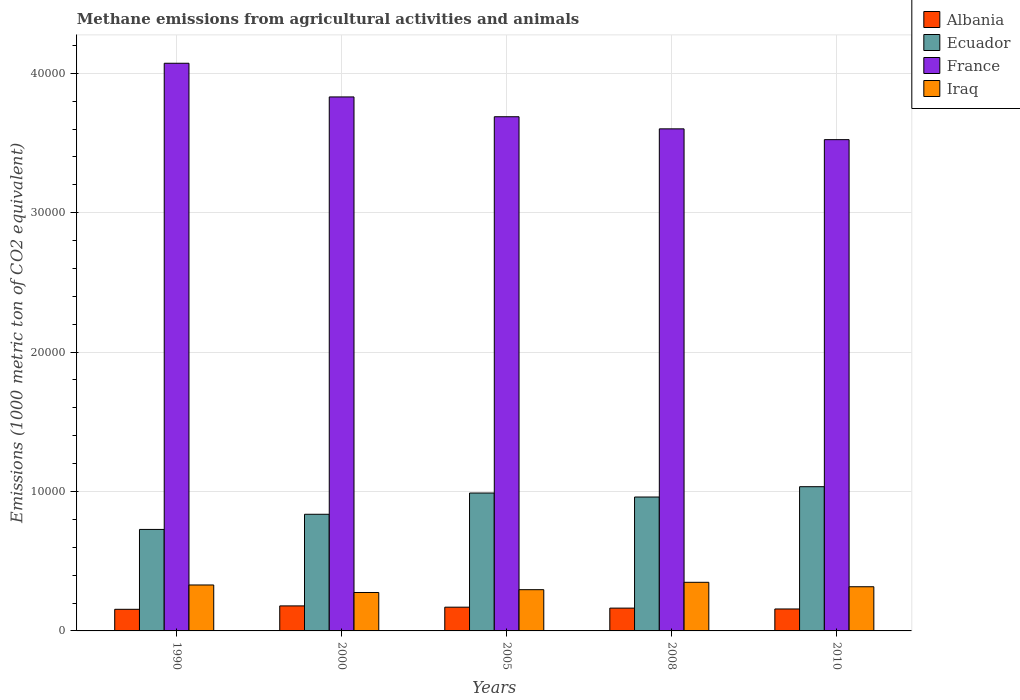How many bars are there on the 3rd tick from the right?
Provide a succinct answer. 4. What is the label of the 5th group of bars from the left?
Your answer should be compact. 2010. In how many cases, is the number of bars for a given year not equal to the number of legend labels?
Offer a terse response. 0. What is the amount of methane emitted in Albania in 2000?
Provide a succinct answer. 1794.6. Across all years, what is the maximum amount of methane emitted in Albania?
Offer a very short reply. 1794.6. Across all years, what is the minimum amount of methane emitted in Iraq?
Make the answer very short. 2756.2. In which year was the amount of methane emitted in Albania maximum?
Provide a short and direct response. 2000. What is the total amount of methane emitted in Iraq in the graph?
Give a very brief answer. 1.57e+04. What is the difference between the amount of methane emitted in Ecuador in 1990 and that in 2010?
Offer a very short reply. -3065.8. What is the difference between the amount of methane emitted in Iraq in 2000 and the amount of methane emitted in Ecuador in 2010?
Provide a short and direct response. -7589.6. What is the average amount of methane emitted in Albania per year?
Ensure brevity in your answer.  1651.66. In the year 2010, what is the difference between the amount of methane emitted in Ecuador and amount of methane emitted in France?
Give a very brief answer. -2.49e+04. In how many years, is the amount of methane emitted in Albania greater than 10000 1000 metric ton?
Ensure brevity in your answer.  0. What is the ratio of the amount of methane emitted in France in 2000 to that in 2010?
Provide a succinct answer. 1.09. Is the amount of methane emitted in Ecuador in 1990 less than that in 2008?
Make the answer very short. Yes. What is the difference between the highest and the second highest amount of methane emitted in Iraq?
Ensure brevity in your answer.  191.6. What is the difference between the highest and the lowest amount of methane emitted in France?
Offer a terse response. 5479. Is it the case that in every year, the sum of the amount of methane emitted in Ecuador and amount of methane emitted in Iraq is greater than the sum of amount of methane emitted in Albania and amount of methane emitted in France?
Your answer should be compact. No. What does the 1st bar from the left in 2010 represents?
Provide a short and direct response. Albania. How many bars are there?
Ensure brevity in your answer.  20. Are all the bars in the graph horizontal?
Your answer should be very brief. No. What is the difference between two consecutive major ticks on the Y-axis?
Provide a short and direct response. 10000. Are the values on the major ticks of Y-axis written in scientific E-notation?
Ensure brevity in your answer.  No. How are the legend labels stacked?
Give a very brief answer. Vertical. What is the title of the graph?
Ensure brevity in your answer.  Methane emissions from agricultural activities and animals. What is the label or title of the Y-axis?
Keep it short and to the point. Emissions (1000 metric ton of CO2 equivalent). What is the Emissions (1000 metric ton of CO2 equivalent) of Albania in 1990?
Offer a very short reply. 1550.9. What is the Emissions (1000 metric ton of CO2 equivalent) in Ecuador in 1990?
Keep it short and to the point. 7280. What is the Emissions (1000 metric ton of CO2 equivalent) of France in 1990?
Your answer should be compact. 4.07e+04. What is the Emissions (1000 metric ton of CO2 equivalent) of Iraq in 1990?
Your answer should be compact. 3295.9. What is the Emissions (1000 metric ton of CO2 equivalent) in Albania in 2000?
Keep it short and to the point. 1794.6. What is the Emissions (1000 metric ton of CO2 equivalent) in Ecuador in 2000?
Ensure brevity in your answer.  8366.7. What is the Emissions (1000 metric ton of CO2 equivalent) in France in 2000?
Your response must be concise. 3.83e+04. What is the Emissions (1000 metric ton of CO2 equivalent) of Iraq in 2000?
Offer a very short reply. 2756.2. What is the Emissions (1000 metric ton of CO2 equivalent) of Albania in 2005?
Your response must be concise. 1702.9. What is the Emissions (1000 metric ton of CO2 equivalent) of Ecuador in 2005?
Offer a very short reply. 9891. What is the Emissions (1000 metric ton of CO2 equivalent) of France in 2005?
Your response must be concise. 3.69e+04. What is the Emissions (1000 metric ton of CO2 equivalent) of Iraq in 2005?
Give a very brief answer. 2958.3. What is the Emissions (1000 metric ton of CO2 equivalent) in Albania in 2008?
Your response must be concise. 1635.8. What is the Emissions (1000 metric ton of CO2 equivalent) in Ecuador in 2008?
Make the answer very short. 9604.8. What is the Emissions (1000 metric ton of CO2 equivalent) of France in 2008?
Provide a succinct answer. 3.60e+04. What is the Emissions (1000 metric ton of CO2 equivalent) of Iraq in 2008?
Provide a succinct answer. 3487.5. What is the Emissions (1000 metric ton of CO2 equivalent) in Albania in 2010?
Your answer should be compact. 1574.1. What is the Emissions (1000 metric ton of CO2 equivalent) of Ecuador in 2010?
Offer a terse response. 1.03e+04. What is the Emissions (1000 metric ton of CO2 equivalent) in France in 2010?
Provide a succinct answer. 3.52e+04. What is the Emissions (1000 metric ton of CO2 equivalent) in Iraq in 2010?
Your answer should be very brief. 3168.9. Across all years, what is the maximum Emissions (1000 metric ton of CO2 equivalent) in Albania?
Your answer should be very brief. 1794.6. Across all years, what is the maximum Emissions (1000 metric ton of CO2 equivalent) of Ecuador?
Your response must be concise. 1.03e+04. Across all years, what is the maximum Emissions (1000 metric ton of CO2 equivalent) of France?
Ensure brevity in your answer.  4.07e+04. Across all years, what is the maximum Emissions (1000 metric ton of CO2 equivalent) in Iraq?
Make the answer very short. 3487.5. Across all years, what is the minimum Emissions (1000 metric ton of CO2 equivalent) of Albania?
Ensure brevity in your answer.  1550.9. Across all years, what is the minimum Emissions (1000 metric ton of CO2 equivalent) of Ecuador?
Your response must be concise. 7280. Across all years, what is the minimum Emissions (1000 metric ton of CO2 equivalent) in France?
Ensure brevity in your answer.  3.52e+04. Across all years, what is the minimum Emissions (1000 metric ton of CO2 equivalent) in Iraq?
Your answer should be compact. 2756.2. What is the total Emissions (1000 metric ton of CO2 equivalent) in Albania in the graph?
Your response must be concise. 8258.3. What is the total Emissions (1000 metric ton of CO2 equivalent) of Ecuador in the graph?
Offer a very short reply. 4.55e+04. What is the total Emissions (1000 metric ton of CO2 equivalent) in France in the graph?
Keep it short and to the point. 1.87e+05. What is the total Emissions (1000 metric ton of CO2 equivalent) in Iraq in the graph?
Your response must be concise. 1.57e+04. What is the difference between the Emissions (1000 metric ton of CO2 equivalent) of Albania in 1990 and that in 2000?
Offer a very short reply. -243.7. What is the difference between the Emissions (1000 metric ton of CO2 equivalent) of Ecuador in 1990 and that in 2000?
Give a very brief answer. -1086.7. What is the difference between the Emissions (1000 metric ton of CO2 equivalent) in France in 1990 and that in 2000?
Offer a terse response. 2415.3. What is the difference between the Emissions (1000 metric ton of CO2 equivalent) of Iraq in 1990 and that in 2000?
Provide a succinct answer. 539.7. What is the difference between the Emissions (1000 metric ton of CO2 equivalent) in Albania in 1990 and that in 2005?
Make the answer very short. -152. What is the difference between the Emissions (1000 metric ton of CO2 equivalent) of Ecuador in 1990 and that in 2005?
Your response must be concise. -2611. What is the difference between the Emissions (1000 metric ton of CO2 equivalent) of France in 1990 and that in 2005?
Ensure brevity in your answer.  3836.5. What is the difference between the Emissions (1000 metric ton of CO2 equivalent) in Iraq in 1990 and that in 2005?
Offer a terse response. 337.6. What is the difference between the Emissions (1000 metric ton of CO2 equivalent) of Albania in 1990 and that in 2008?
Offer a terse response. -84.9. What is the difference between the Emissions (1000 metric ton of CO2 equivalent) of Ecuador in 1990 and that in 2008?
Keep it short and to the point. -2324.8. What is the difference between the Emissions (1000 metric ton of CO2 equivalent) of France in 1990 and that in 2008?
Keep it short and to the point. 4704.7. What is the difference between the Emissions (1000 metric ton of CO2 equivalent) of Iraq in 1990 and that in 2008?
Your response must be concise. -191.6. What is the difference between the Emissions (1000 metric ton of CO2 equivalent) in Albania in 1990 and that in 2010?
Keep it short and to the point. -23.2. What is the difference between the Emissions (1000 metric ton of CO2 equivalent) of Ecuador in 1990 and that in 2010?
Provide a succinct answer. -3065.8. What is the difference between the Emissions (1000 metric ton of CO2 equivalent) of France in 1990 and that in 2010?
Offer a terse response. 5479. What is the difference between the Emissions (1000 metric ton of CO2 equivalent) in Iraq in 1990 and that in 2010?
Make the answer very short. 127. What is the difference between the Emissions (1000 metric ton of CO2 equivalent) of Albania in 2000 and that in 2005?
Offer a terse response. 91.7. What is the difference between the Emissions (1000 metric ton of CO2 equivalent) in Ecuador in 2000 and that in 2005?
Offer a very short reply. -1524.3. What is the difference between the Emissions (1000 metric ton of CO2 equivalent) of France in 2000 and that in 2005?
Give a very brief answer. 1421.2. What is the difference between the Emissions (1000 metric ton of CO2 equivalent) of Iraq in 2000 and that in 2005?
Make the answer very short. -202.1. What is the difference between the Emissions (1000 metric ton of CO2 equivalent) in Albania in 2000 and that in 2008?
Ensure brevity in your answer.  158.8. What is the difference between the Emissions (1000 metric ton of CO2 equivalent) of Ecuador in 2000 and that in 2008?
Provide a succinct answer. -1238.1. What is the difference between the Emissions (1000 metric ton of CO2 equivalent) of France in 2000 and that in 2008?
Your response must be concise. 2289.4. What is the difference between the Emissions (1000 metric ton of CO2 equivalent) in Iraq in 2000 and that in 2008?
Offer a terse response. -731.3. What is the difference between the Emissions (1000 metric ton of CO2 equivalent) of Albania in 2000 and that in 2010?
Your answer should be compact. 220.5. What is the difference between the Emissions (1000 metric ton of CO2 equivalent) in Ecuador in 2000 and that in 2010?
Keep it short and to the point. -1979.1. What is the difference between the Emissions (1000 metric ton of CO2 equivalent) of France in 2000 and that in 2010?
Provide a short and direct response. 3063.7. What is the difference between the Emissions (1000 metric ton of CO2 equivalent) of Iraq in 2000 and that in 2010?
Keep it short and to the point. -412.7. What is the difference between the Emissions (1000 metric ton of CO2 equivalent) in Albania in 2005 and that in 2008?
Provide a succinct answer. 67.1. What is the difference between the Emissions (1000 metric ton of CO2 equivalent) of Ecuador in 2005 and that in 2008?
Your response must be concise. 286.2. What is the difference between the Emissions (1000 metric ton of CO2 equivalent) of France in 2005 and that in 2008?
Provide a succinct answer. 868.2. What is the difference between the Emissions (1000 metric ton of CO2 equivalent) of Iraq in 2005 and that in 2008?
Give a very brief answer. -529.2. What is the difference between the Emissions (1000 metric ton of CO2 equivalent) of Albania in 2005 and that in 2010?
Your response must be concise. 128.8. What is the difference between the Emissions (1000 metric ton of CO2 equivalent) in Ecuador in 2005 and that in 2010?
Provide a short and direct response. -454.8. What is the difference between the Emissions (1000 metric ton of CO2 equivalent) of France in 2005 and that in 2010?
Offer a terse response. 1642.5. What is the difference between the Emissions (1000 metric ton of CO2 equivalent) in Iraq in 2005 and that in 2010?
Your response must be concise. -210.6. What is the difference between the Emissions (1000 metric ton of CO2 equivalent) in Albania in 2008 and that in 2010?
Keep it short and to the point. 61.7. What is the difference between the Emissions (1000 metric ton of CO2 equivalent) of Ecuador in 2008 and that in 2010?
Give a very brief answer. -741. What is the difference between the Emissions (1000 metric ton of CO2 equivalent) of France in 2008 and that in 2010?
Your answer should be compact. 774.3. What is the difference between the Emissions (1000 metric ton of CO2 equivalent) in Iraq in 2008 and that in 2010?
Provide a short and direct response. 318.6. What is the difference between the Emissions (1000 metric ton of CO2 equivalent) in Albania in 1990 and the Emissions (1000 metric ton of CO2 equivalent) in Ecuador in 2000?
Offer a very short reply. -6815.8. What is the difference between the Emissions (1000 metric ton of CO2 equivalent) of Albania in 1990 and the Emissions (1000 metric ton of CO2 equivalent) of France in 2000?
Ensure brevity in your answer.  -3.68e+04. What is the difference between the Emissions (1000 metric ton of CO2 equivalent) of Albania in 1990 and the Emissions (1000 metric ton of CO2 equivalent) of Iraq in 2000?
Ensure brevity in your answer.  -1205.3. What is the difference between the Emissions (1000 metric ton of CO2 equivalent) of Ecuador in 1990 and the Emissions (1000 metric ton of CO2 equivalent) of France in 2000?
Ensure brevity in your answer.  -3.10e+04. What is the difference between the Emissions (1000 metric ton of CO2 equivalent) of Ecuador in 1990 and the Emissions (1000 metric ton of CO2 equivalent) of Iraq in 2000?
Your response must be concise. 4523.8. What is the difference between the Emissions (1000 metric ton of CO2 equivalent) in France in 1990 and the Emissions (1000 metric ton of CO2 equivalent) in Iraq in 2000?
Offer a terse response. 3.80e+04. What is the difference between the Emissions (1000 metric ton of CO2 equivalent) in Albania in 1990 and the Emissions (1000 metric ton of CO2 equivalent) in Ecuador in 2005?
Keep it short and to the point. -8340.1. What is the difference between the Emissions (1000 metric ton of CO2 equivalent) of Albania in 1990 and the Emissions (1000 metric ton of CO2 equivalent) of France in 2005?
Provide a short and direct response. -3.53e+04. What is the difference between the Emissions (1000 metric ton of CO2 equivalent) in Albania in 1990 and the Emissions (1000 metric ton of CO2 equivalent) in Iraq in 2005?
Offer a terse response. -1407.4. What is the difference between the Emissions (1000 metric ton of CO2 equivalent) of Ecuador in 1990 and the Emissions (1000 metric ton of CO2 equivalent) of France in 2005?
Ensure brevity in your answer.  -2.96e+04. What is the difference between the Emissions (1000 metric ton of CO2 equivalent) of Ecuador in 1990 and the Emissions (1000 metric ton of CO2 equivalent) of Iraq in 2005?
Provide a succinct answer. 4321.7. What is the difference between the Emissions (1000 metric ton of CO2 equivalent) in France in 1990 and the Emissions (1000 metric ton of CO2 equivalent) in Iraq in 2005?
Your answer should be very brief. 3.78e+04. What is the difference between the Emissions (1000 metric ton of CO2 equivalent) in Albania in 1990 and the Emissions (1000 metric ton of CO2 equivalent) in Ecuador in 2008?
Your answer should be compact. -8053.9. What is the difference between the Emissions (1000 metric ton of CO2 equivalent) in Albania in 1990 and the Emissions (1000 metric ton of CO2 equivalent) in France in 2008?
Provide a succinct answer. -3.45e+04. What is the difference between the Emissions (1000 metric ton of CO2 equivalent) of Albania in 1990 and the Emissions (1000 metric ton of CO2 equivalent) of Iraq in 2008?
Your response must be concise. -1936.6. What is the difference between the Emissions (1000 metric ton of CO2 equivalent) of Ecuador in 1990 and the Emissions (1000 metric ton of CO2 equivalent) of France in 2008?
Provide a succinct answer. -2.87e+04. What is the difference between the Emissions (1000 metric ton of CO2 equivalent) of Ecuador in 1990 and the Emissions (1000 metric ton of CO2 equivalent) of Iraq in 2008?
Your answer should be very brief. 3792.5. What is the difference between the Emissions (1000 metric ton of CO2 equivalent) of France in 1990 and the Emissions (1000 metric ton of CO2 equivalent) of Iraq in 2008?
Your response must be concise. 3.72e+04. What is the difference between the Emissions (1000 metric ton of CO2 equivalent) of Albania in 1990 and the Emissions (1000 metric ton of CO2 equivalent) of Ecuador in 2010?
Offer a terse response. -8794.9. What is the difference between the Emissions (1000 metric ton of CO2 equivalent) in Albania in 1990 and the Emissions (1000 metric ton of CO2 equivalent) in France in 2010?
Keep it short and to the point. -3.37e+04. What is the difference between the Emissions (1000 metric ton of CO2 equivalent) in Albania in 1990 and the Emissions (1000 metric ton of CO2 equivalent) in Iraq in 2010?
Your response must be concise. -1618. What is the difference between the Emissions (1000 metric ton of CO2 equivalent) of Ecuador in 1990 and the Emissions (1000 metric ton of CO2 equivalent) of France in 2010?
Your answer should be compact. -2.80e+04. What is the difference between the Emissions (1000 metric ton of CO2 equivalent) of Ecuador in 1990 and the Emissions (1000 metric ton of CO2 equivalent) of Iraq in 2010?
Keep it short and to the point. 4111.1. What is the difference between the Emissions (1000 metric ton of CO2 equivalent) in France in 1990 and the Emissions (1000 metric ton of CO2 equivalent) in Iraq in 2010?
Your response must be concise. 3.75e+04. What is the difference between the Emissions (1000 metric ton of CO2 equivalent) in Albania in 2000 and the Emissions (1000 metric ton of CO2 equivalent) in Ecuador in 2005?
Provide a succinct answer. -8096.4. What is the difference between the Emissions (1000 metric ton of CO2 equivalent) in Albania in 2000 and the Emissions (1000 metric ton of CO2 equivalent) in France in 2005?
Provide a short and direct response. -3.51e+04. What is the difference between the Emissions (1000 metric ton of CO2 equivalent) of Albania in 2000 and the Emissions (1000 metric ton of CO2 equivalent) of Iraq in 2005?
Offer a very short reply. -1163.7. What is the difference between the Emissions (1000 metric ton of CO2 equivalent) of Ecuador in 2000 and the Emissions (1000 metric ton of CO2 equivalent) of France in 2005?
Provide a short and direct response. -2.85e+04. What is the difference between the Emissions (1000 metric ton of CO2 equivalent) of Ecuador in 2000 and the Emissions (1000 metric ton of CO2 equivalent) of Iraq in 2005?
Offer a very short reply. 5408.4. What is the difference between the Emissions (1000 metric ton of CO2 equivalent) in France in 2000 and the Emissions (1000 metric ton of CO2 equivalent) in Iraq in 2005?
Provide a short and direct response. 3.53e+04. What is the difference between the Emissions (1000 metric ton of CO2 equivalent) of Albania in 2000 and the Emissions (1000 metric ton of CO2 equivalent) of Ecuador in 2008?
Your answer should be compact. -7810.2. What is the difference between the Emissions (1000 metric ton of CO2 equivalent) of Albania in 2000 and the Emissions (1000 metric ton of CO2 equivalent) of France in 2008?
Provide a succinct answer. -3.42e+04. What is the difference between the Emissions (1000 metric ton of CO2 equivalent) in Albania in 2000 and the Emissions (1000 metric ton of CO2 equivalent) in Iraq in 2008?
Your response must be concise. -1692.9. What is the difference between the Emissions (1000 metric ton of CO2 equivalent) in Ecuador in 2000 and the Emissions (1000 metric ton of CO2 equivalent) in France in 2008?
Your response must be concise. -2.76e+04. What is the difference between the Emissions (1000 metric ton of CO2 equivalent) in Ecuador in 2000 and the Emissions (1000 metric ton of CO2 equivalent) in Iraq in 2008?
Offer a very short reply. 4879.2. What is the difference between the Emissions (1000 metric ton of CO2 equivalent) of France in 2000 and the Emissions (1000 metric ton of CO2 equivalent) of Iraq in 2008?
Ensure brevity in your answer.  3.48e+04. What is the difference between the Emissions (1000 metric ton of CO2 equivalent) of Albania in 2000 and the Emissions (1000 metric ton of CO2 equivalent) of Ecuador in 2010?
Offer a very short reply. -8551.2. What is the difference between the Emissions (1000 metric ton of CO2 equivalent) in Albania in 2000 and the Emissions (1000 metric ton of CO2 equivalent) in France in 2010?
Your response must be concise. -3.34e+04. What is the difference between the Emissions (1000 metric ton of CO2 equivalent) of Albania in 2000 and the Emissions (1000 metric ton of CO2 equivalent) of Iraq in 2010?
Provide a short and direct response. -1374.3. What is the difference between the Emissions (1000 metric ton of CO2 equivalent) in Ecuador in 2000 and the Emissions (1000 metric ton of CO2 equivalent) in France in 2010?
Your response must be concise. -2.69e+04. What is the difference between the Emissions (1000 metric ton of CO2 equivalent) of Ecuador in 2000 and the Emissions (1000 metric ton of CO2 equivalent) of Iraq in 2010?
Offer a terse response. 5197.8. What is the difference between the Emissions (1000 metric ton of CO2 equivalent) in France in 2000 and the Emissions (1000 metric ton of CO2 equivalent) in Iraq in 2010?
Your answer should be compact. 3.51e+04. What is the difference between the Emissions (1000 metric ton of CO2 equivalent) in Albania in 2005 and the Emissions (1000 metric ton of CO2 equivalent) in Ecuador in 2008?
Your answer should be very brief. -7901.9. What is the difference between the Emissions (1000 metric ton of CO2 equivalent) in Albania in 2005 and the Emissions (1000 metric ton of CO2 equivalent) in France in 2008?
Keep it short and to the point. -3.43e+04. What is the difference between the Emissions (1000 metric ton of CO2 equivalent) of Albania in 2005 and the Emissions (1000 metric ton of CO2 equivalent) of Iraq in 2008?
Your response must be concise. -1784.6. What is the difference between the Emissions (1000 metric ton of CO2 equivalent) in Ecuador in 2005 and the Emissions (1000 metric ton of CO2 equivalent) in France in 2008?
Give a very brief answer. -2.61e+04. What is the difference between the Emissions (1000 metric ton of CO2 equivalent) in Ecuador in 2005 and the Emissions (1000 metric ton of CO2 equivalent) in Iraq in 2008?
Provide a succinct answer. 6403.5. What is the difference between the Emissions (1000 metric ton of CO2 equivalent) of France in 2005 and the Emissions (1000 metric ton of CO2 equivalent) of Iraq in 2008?
Your answer should be very brief. 3.34e+04. What is the difference between the Emissions (1000 metric ton of CO2 equivalent) of Albania in 2005 and the Emissions (1000 metric ton of CO2 equivalent) of Ecuador in 2010?
Ensure brevity in your answer.  -8642.9. What is the difference between the Emissions (1000 metric ton of CO2 equivalent) in Albania in 2005 and the Emissions (1000 metric ton of CO2 equivalent) in France in 2010?
Keep it short and to the point. -3.35e+04. What is the difference between the Emissions (1000 metric ton of CO2 equivalent) of Albania in 2005 and the Emissions (1000 metric ton of CO2 equivalent) of Iraq in 2010?
Your answer should be very brief. -1466. What is the difference between the Emissions (1000 metric ton of CO2 equivalent) of Ecuador in 2005 and the Emissions (1000 metric ton of CO2 equivalent) of France in 2010?
Offer a terse response. -2.53e+04. What is the difference between the Emissions (1000 metric ton of CO2 equivalent) in Ecuador in 2005 and the Emissions (1000 metric ton of CO2 equivalent) in Iraq in 2010?
Your response must be concise. 6722.1. What is the difference between the Emissions (1000 metric ton of CO2 equivalent) in France in 2005 and the Emissions (1000 metric ton of CO2 equivalent) in Iraq in 2010?
Your answer should be compact. 3.37e+04. What is the difference between the Emissions (1000 metric ton of CO2 equivalent) of Albania in 2008 and the Emissions (1000 metric ton of CO2 equivalent) of Ecuador in 2010?
Your answer should be very brief. -8710. What is the difference between the Emissions (1000 metric ton of CO2 equivalent) in Albania in 2008 and the Emissions (1000 metric ton of CO2 equivalent) in France in 2010?
Provide a short and direct response. -3.36e+04. What is the difference between the Emissions (1000 metric ton of CO2 equivalent) of Albania in 2008 and the Emissions (1000 metric ton of CO2 equivalent) of Iraq in 2010?
Provide a short and direct response. -1533.1. What is the difference between the Emissions (1000 metric ton of CO2 equivalent) of Ecuador in 2008 and the Emissions (1000 metric ton of CO2 equivalent) of France in 2010?
Your response must be concise. -2.56e+04. What is the difference between the Emissions (1000 metric ton of CO2 equivalent) in Ecuador in 2008 and the Emissions (1000 metric ton of CO2 equivalent) in Iraq in 2010?
Ensure brevity in your answer.  6435.9. What is the difference between the Emissions (1000 metric ton of CO2 equivalent) of France in 2008 and the Emissions (1000 metric ton of CO2 equivalent) of Iraq in 2010?
Ensure brevity in your answer.  3.28e+04. What is the average Emissions (1000 metric ton of CO2 equivalent) of Albania per year?
Give a very brief answer. 1651.66. What is the average Emissions (1000 metric ton of CO2 equivalent) of Ecuador per year?
Make the answer very short. 9097.66. What is the average Emissions (1000 metric ton of CO2 equivalent) in France per year?
Offer a terse response. 3.74e+04. What is the average Emissions (1000 metric ton of CO2 equivalent) of Iraq per year?
Make the answer very short. 3133.36. In the year 1990, what is the difference between the Emissions (1000 metric ton of CO2 equivalent) of Albania and Emissions (1000 metric ton of CO2 equivalent) of Ecuador?
Provide a short and direct response. -5729.1. In the year 1990, what is the difference between the Emissions (1000 metric ton of CO2 equivalent) in Albania and Emissions (1000 metric ton of CO2 equivalent) in France?
Your answer should be compact. -3.92e+04. In the year 1990, what is the difference between the Emissions (1000 metric ton of CO2 equivalent) of Albania and Emissions (1000 metric ton of CO2 equivalent) of Iraq?
Provide a succinct answer. -1745. In the year 1990, what is the difference between the Emissions (1000 metric ton of CO2 equivalent) in Ecuador and Emissions (1000 metric ton of CO2 equivalent) in France?
Your response must be concise. -3.34e+04. In the year 1990, what is the difference between the Emissions (1000 metric ton of CO2 equivalent) in Ecuador and Emissions (1000 metric ton of CO2 equivalent) in Iraq?
Keep it short and to the point. 3984.1. In the year 1990, what is the difference between the Emissions (1000 metric ton of CO2 equivalent) of France and Emissions (1000 metric ton of CO2 equivalent) of Iraq?
Provide a short and direct response. 3.74e+04. In the year 2000, what is the difference between the Emissions (1000 metric ton of CO2 equivalent) in Albania and Emissions (1000 metric ton of CO2 equivalent) in Ecuador?
Offer a very short reply. -6572.1. In the year 2000, what is the difference between the Emissions (1000 metric ton of CO2 equivalent) in Albania and Emissions (1000 metric ton of CO2 equivalent) in France?
Your answer should be compact. -3.65e+04. In the year 2000, what is the difference between the Emissions (1000 metric ton of CO2 equivalent) in Albania and Emissions (1000 metric ton of CO2 equivalent) in Iraq?
Provide a succinct answer. -961.6. In the year 2000, what is the difference between the Emissions (1000 metric ton of CO2 equivalent) in Ecuador and Emissions (1000 metric ton of CO2 equivalent) in France?
Provide a short and direct response. -2.99e+04. In the year 2000, what is the difference between the Emissions (1000 metric ton of CO2 equivalent) of Ecuador and Emissions (1000 metric ton of CO2 equivalent) of Iraq?
Give a very brief answer. 5610.5. In the year 2000, what is the difference between the Emissions (1000 metric ton of CO2 equivalent) in France and Emissions (1000 metric ton of CO2 equivalent) in Iraq?
Provide a short and direct response. 3.55e+04. In the year 2005, what is the difference between the Emissions (1000 metric ton of CO2 equivalent) in Albania and Emissions (1000 metric ton of CO2 equivalent) in Ecuador?
Give a very brief answer. -8188.1. In the year 2005, what is the difference between the Emissions (1000 metric ton of CO2 equivalent) in Albania and Emissions (1000 metric ton of CO2 equivalent) in France?
Make the answer very short. -3.52e+04. In the year 2005, what is the difference between the Emissions (1000 metric ton of CO2 equivalent) of Albania and Emissions (1000 metric ton of CO2 equivalent) of Iraq?
Provide a short and direct response. -1255.4. In the year 2005, what is the difference between the Emissions (1000 metric ton of CO2 equivalent) of Ecuador and Emissions (1000 metric ton of CO2 equivalent) of France?
Give a very brief answer. -2.70e+04. In the year 2005, what is the difference between the Emissions (1000 metric ton of CO2 equivalent) of Ecuador and Emissions (1000 metric ton of CO2 equivalent) of Iraq?
Ensure brevity in your answer.  6932.7. In the year 2005, what is the difference between the Emissions (1000 metric ton of CO2 equivalent) of France and Emissions (1000 metric ton of CO2 equivalent) of Iraq?
Ensure brevity in your answer.  3.39e+04. In the year 2008, what is the difference between the Emissions (1000 metric ton of CO2 equivalent) of Albania and Emissions (1000 metric ton of CO2 equivalent) of Ecuador?
Make the answer very short. -7969. In the year 2008, what is the difference between the Emissions (1000 metric ton of CO2 equivalent) of Albania and Emissions (1000 metric ton of CO2 equivalent) of France?
Provide a succinct answer. -3.44e+04. In the year 2008, what is the difference between the Emissions (1000 metric ton of CO2 equivalent) of Albania and Emissions (1000 metric ton of CO2 equivalent) of Iraq?
Provide a short and direct response. -1851.7. In the year 2008, what is the difference between the Emissions (1000 metric ton of CO2 equivalent) in Ecuador and Emissions (1000 metric ton of CO2 equivalent) in France?
Your answer should be compact. -2.64e+04. In the year 2008, what is the difference between the Emissions (1000 metric ton of CO2 equivalent) of Ecuador and Emissions (1000 metric ton of CO2 equivalent) of Iraq?
Keep it short and to the point. 6117.3. In the year 2008, what is the difference between the Emissions (1000 metric ton of CO2 equivalent) of France and Emissions (1000 metric ton of CO2 equivalent) of Iraq?
Your response must be concise. 3.25e+04. In the year 2010, what is the difference between the Emissions (1000 metric ton of CO2 equivalent) in Albania and Emissions (1000 metric ton of CO2 equivalent) in Ecuador?
Offer a very short reply. -8771.7. In the year 2010, what is the difference between the Emissions (1000 metric ton of CO2 equivalent) in Albania and Emissions (1000 metric ton of CO2 equivalent) in France?
Provide a succinct answer. -3.37e+04. In the year 2010, what is the difference between the Emissions (1000 metric ton of CO2 equivalent) in Albania and Emissions (1000 metric ton of CO2 equivalent) in Iraq?
Your answer should be very brief. -1594.8. In the year 2010, what is the difference between the Emissions (1000 metric ton of CO2 equivalent) in Ecuador and Emissions (1000 metric ton of CO2 equivalent) in France?
Provide a short and direct response. -2.49e+04. In the year 2010, what is the difference between the Emissions (1000 metric ton of CO2 equivalent) of Ecuador and Emissions (1000 metric ton of CO2 equivalent) of Iraq?
Your answer should be very brief. 7176.9. In the year 2010, what is the difference between the Emissions (1000 metric ton of CO2 equivalent) of France and Emissions (1000 metric ton of CO2 equivalent) of Iraq?
Your answer should be compact. 3.21e+04. What is the ratio of the Emissions (1000 metric ton of CO2 equivalent) in Albania in 1990 to that in 2000?
Ensure brevity in your answer.  0.86. What is the ratio of the Emissions (1000 metric ton of CO2 equivalent) in Ecuador in 1990 to that in 2000?
Provide a succinct answer. 0.87. What is the ratio of the Emissions (1000 metric ton of CO2 equivalent) in France in 1990 to that in 2000?
Your response must be concise. 1.06. What is the ratio of the Emissions (1000 metric ton of CO2 equivalent) of Iraq in 1990 to that in 2000?
Give a very brief answer. 1.2. What is the ratio of the Emissions (1000 metric ton of CO2 equivalent) in Albania in 1990 to that in 2005?
Keep it short and to the point. 0.91. What is the ratio of the Emissions (1000 metric ton of CO2 equivalent) of Ecuador in 1990 to that in 2005?
Provide a short and direct response. 0.74. What is the ratio of the Emissions (1000 metric ton of CO2 equivalent) in France in 1990 to that in 2005?
Your answer should be very brief. 1.1. What is the ratio of the Emissions (1000 metric ton of CO2 equivalent) in Iraq in 1990 to that in 2005?
Your response must be concise. 1.11. What is the ratio of the Emissions (1000 metric ton of CO2 equivalent) in Albania in 1990 to that in 2008?
Provide a short and direct response. 0.95. What is the ratio of the Emissions (1000 metric ton of CO2 equivalent) in Ecuador in 1990 to that in 2008?
Provide a short and direct response. 0.76. What is the ratio of the Emissions (1000 metric ton of CO2 equivalent) of France in 1990 to that in 2008?
Make the answer very short. 1.13. What is the ratio of the Emissions (1000 metric ton of CO2 equivalent) in Iraq in 1990 to that in 2008?
Ensure brevity in your answer.  0.95. What is the ratio of the Emissions (1000 metric ton of CO2 equivalent) of Albania in 1990 to that in 2010?
Provide a succinct answer. 0.99. What is the ratio of the Emissions (1000 metric ton of CO2 equivalent) of Ecuador in 1990 to that in 2010?
Give a very brief answer. 0.7. What is the ratio of the Emissions (1000 metric ton of CO2 equivalent) of France in 1990 to that in 2010?
Your answer should be compact. 1.16. What is the ratio of the Emissions (1000 metric ton of CO2 equivalent) of Iraq in 1990 to that in 2010?
Give a very brief answer. 1.04. What is the ratio of the Emissions (1000 metric ton of CO2 equivalent) of Albania in 2000 to that in 2005?
Your answer should be compact. 1.05. What is the ratio of the Emissions (1000 metric ton of CO2 equivalent) in Ecuador in 2000 to that in 2005?
Offer a terse response. 0.85. What is the ratio of the Emissions (1000 metric ton of CO2 equivalent) in France in 2000 to that in 2005?
Your response must be concise. 1.04. What is the ratio of the Emissions (1000 metric ton of CO2 equivalent) of Iraq in 2000 to that in 2005?
Your answer should be compact. 0.93. What is the ratio of the Emissions (1000 metric ton of CO2 equivalent) of Albania in 2000 to that in 2008?
Offer a very short reply. 1.1. What is the ratio of the Emissions (1000 metric ton of CO2 equivalent) in Ecuador in 2000 to that in 2008?
Your answer should be very brief. 0.87. What is the ratio of the Emissions (1000 metric ton of CO2 equivalent) of France in 2000 to that in 2008?
Make the answer very short. 1.06. What is the ratio of the Emissions (1000 metric ton of CO2 equivalent) in Iraq in 2000 to that in 2008?
Offer a terse response. 0.79. What is the ratio of the Emissions (1000 metric ton of CO2 equivalent) in Albania in 2000 to that in 2010?
Provide a short and direct response. 1.14. What is the ratio of the Emissions (1000 metric ton of CO2 equivalent) of Ecuador in 2000 to that in 2010?
Ensure brevity in your answer.  0.81. What is the ratio of the Emissions (1000 metric ton of CO2 equivalent) in France in 2000 to that in 2010?
Make the answer very short. 1.09. What is the ratio of the Emissions (1000 metric ton of CO2 equivalent) of Iraq in 2000 to that in 2010?
Make the answer very short. 0.87. What is the ratio of the Emissions (1000 metric ton of CO2 equivalent) in Albania in 2005 to that in 2008?
Provide a short and direct response. 1.04. What is the ratio of the Emissions (1000 metric ton of CO2 equivalent) in Ecuador in 2005 to that in 2008?
Your answer should be compact. 1.03. What is the ratio of the Emissions (1000 metric ton of CO2 equivalent) of France in 2005 to that in 2008?
Offer a very short reply. 1.02. What is the ratio of the Emissions (1000 metric ton of CO2 equivalent) of Iraq in 2005 to that in 2008?
Your answer should be compact. 0.85. What is the ratio of the Emissions (1000 metric ton of CO2 equivalent) in Albania in 2005 to that in 2010?
Your response must be concise. 1.08. What is the ratio of the Emissions (1000 metric ton of CO2 equivalent) of Ecuador in 2005 to that in 2010?
Your answer should be very brief. 0.96. What is the ratio of the Emissions (1000 metric ton of CO2 equivalent) of France in 2005 to that in 2010?
Ensure brevity in your answer.  1.05. What is the ratio of the Emissions (1000 metric ton of CO2 equivalent) in Iraq in 2005 to that in 2010?
Make the answer very short. 0.93. What is the ratio of the Emissions (1000 metric ton of CO2 equivalent) in Albania in 2008 to that in 2010?
Ensure brevity in your answer.  1.04. What is the ratio of the Emissions (1000 metric ton of CO2 equivalent) of Ecuador in 2008 to that in 2010?
Your response must be concise. 0.93. What is the ratio of the Emissions (1000 metric ton of CO2 equivalent) in Iraq in 2008 to that in 2010?
Your response must be concise. 1.1. What is the difference between the highest and the second highest Emissions (1000 metric ton of CO2 equivalent) of Albania?
Offer a terse response. 91.7. What is the difference between the highest and the second highest Emissions (1000 metric ton of CO2 equivalent) of Ecuador?
Make the answer very short. 454.8. What is the difference between the highest and the second highest Emissions (1000 metric ton of CO2 equivalent) in France?
Give a very brief answer. 2415.3. What is the difference between the highest and the second highest Emissions (1000 metric ton of CO2 equivalent) of Iraq?
Provide a short and direct response. 191.6. What is the difference between the highest and the lowest Emissions (1000 metric ton of CO2 equivalent) in Albania?
Your answer should be compact. 243.7. What is the difference between the highest and the lowest Emissions (1000 metric ton of CO2 equivalent) of Ecuador?
Provide a short and direct response. 3065.8. What is the difference between the highest and the lowest Emissions (1000 metric ton of CO2 equivalent) of France?
Offer a very short reply. 5479. What is the difference between the highest and the lowest Emissions (1000 metric ton of CO2 equivalent) in Iraq?
Offer a terse response. 731.3. 